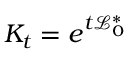Convert formula to latex. <formula><loc_0><loc_0><loc_500><loc_500>{ K } _ { t } = e ^ { t \mathcal { L } _ { 0 } ^ { \ast } }</formula> 